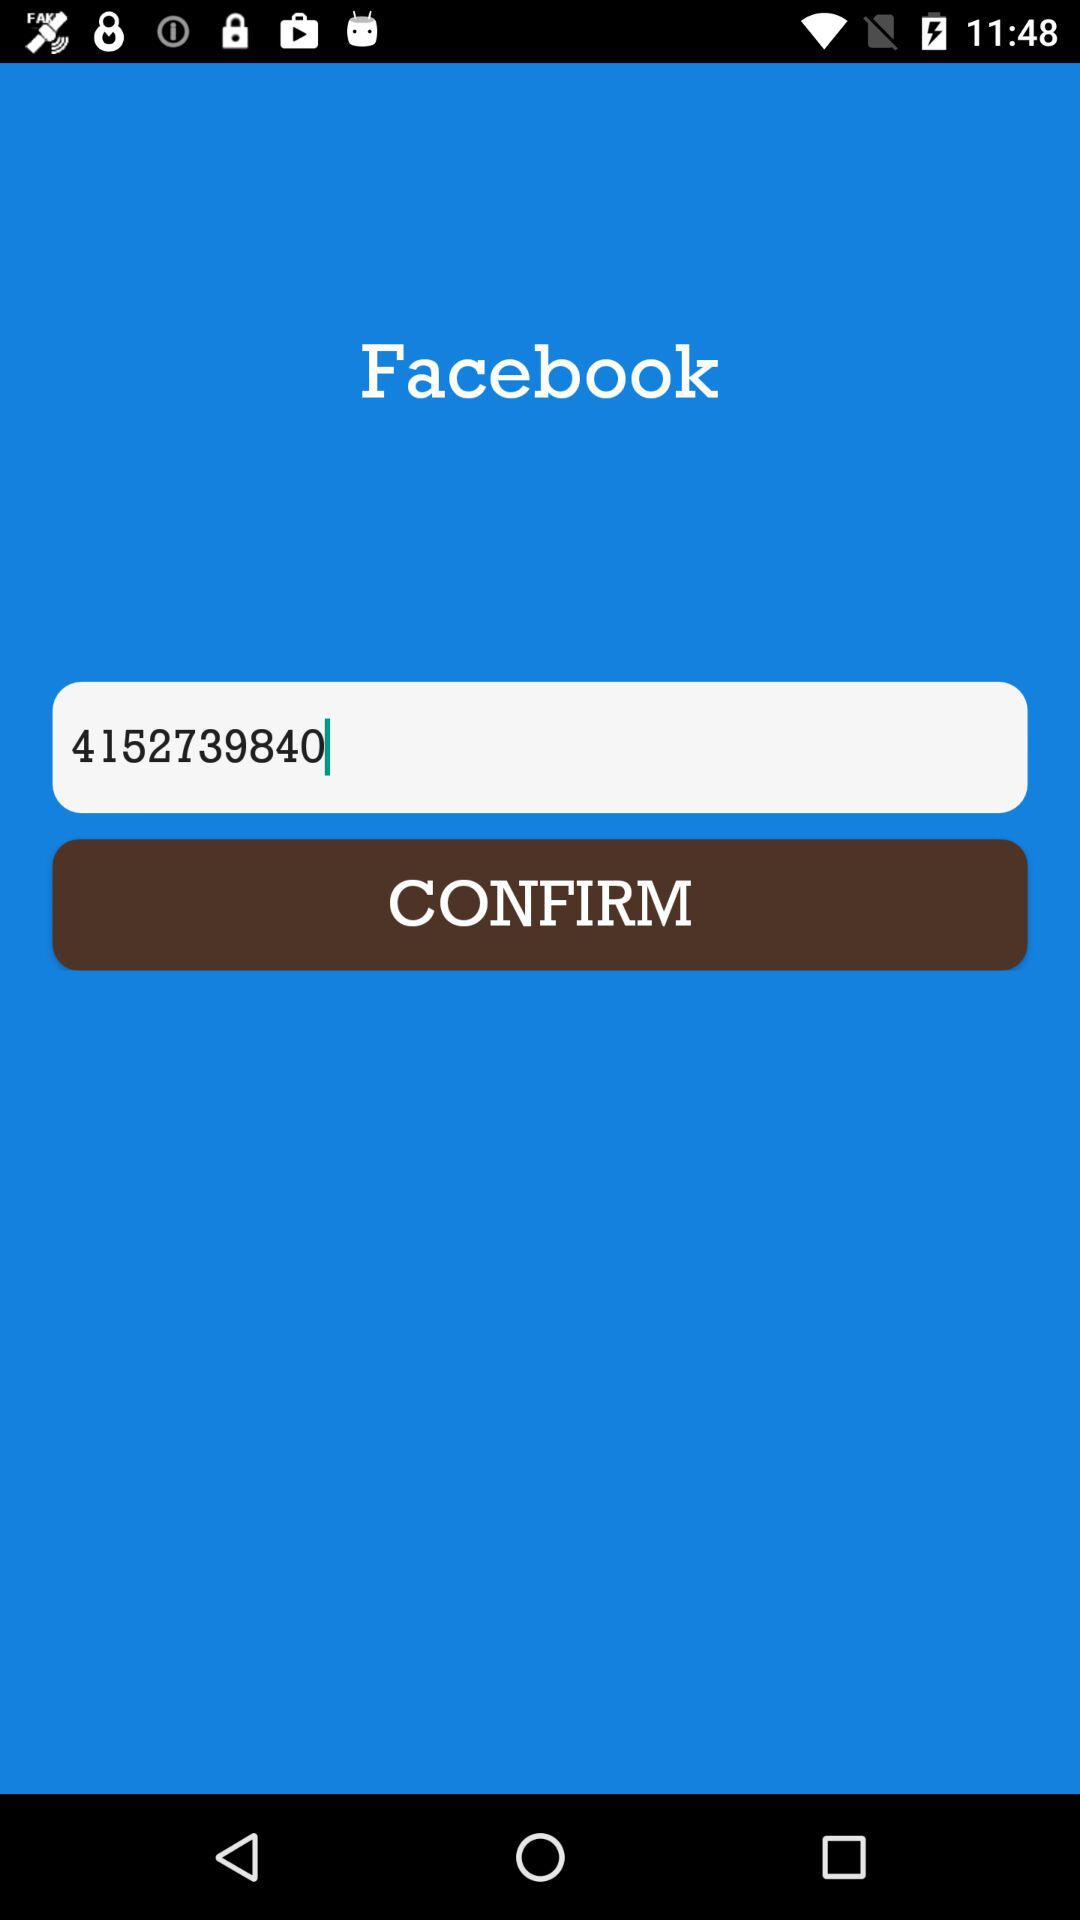What is the entered number? The entered number is 4152739840. 